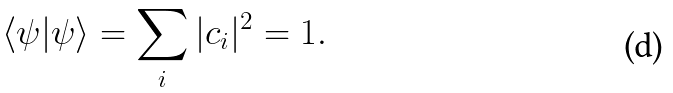<formula> <loc_0><loc_0><loc_500><loc_500>\langle \psi | \psi \rangle = \sum _ { i } | c _ { i } | ^ { 2 } = 1 .</formula> 